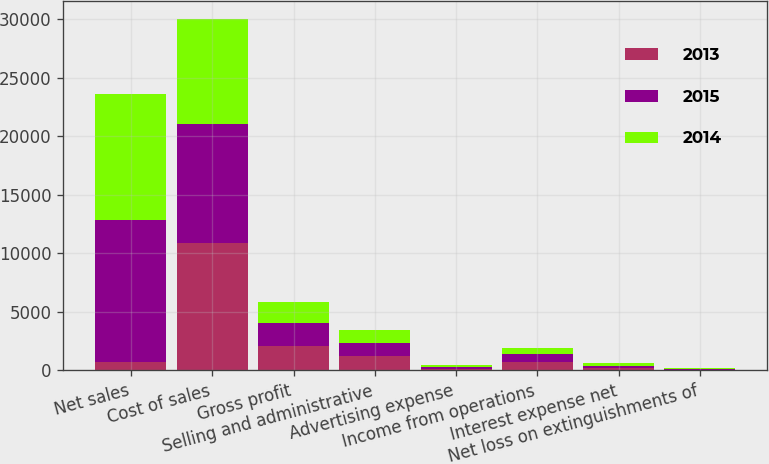<chart> <loc_0><loc_0><loc_500><loc_500><stacked_bar_chart><ecel><fcel>Net sales<fcel>Cost of sales<fcel>Gross profit<fcel>Selling and administrative<fcel>Advertising expense<fcel>Income from operations<fcel>Interest expense net<fcel>Net loss on extinguishments of<nl><fcel>2013<fcel>742<fcel>10872.9<fcel>2115.8<fcel>1226<fcel>147.8<fcel>742<fcel>159.5<fcel>24.3<nl><fcel>2015<fcel>12074.5<fcel>10153.2<fcel>1921.3<fcel>1110.3<fcel>138<fcel>673<fcel>197.3<fcel>90.7<nl><fcel>2014<fcel>10768.6<fcel>9008.3<fcel>1760.3<fcel>1120.9<fcel>130.8<fcel>508.6<fcel>250.1<fcel>64<nl></chart> 